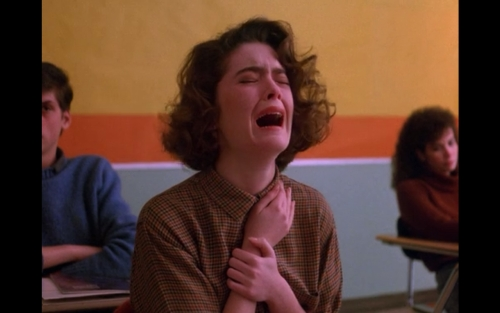How would you rate the lighting of the image?
A. Good
B. Bright
C. Poor
D. Average The lighting in the image appears to be average; it is neither too bright nor too dim, providing sufficient visibility without causing any harsh shadows or overexposure. It's well-balanced to convey the scene and its mood effectively. 